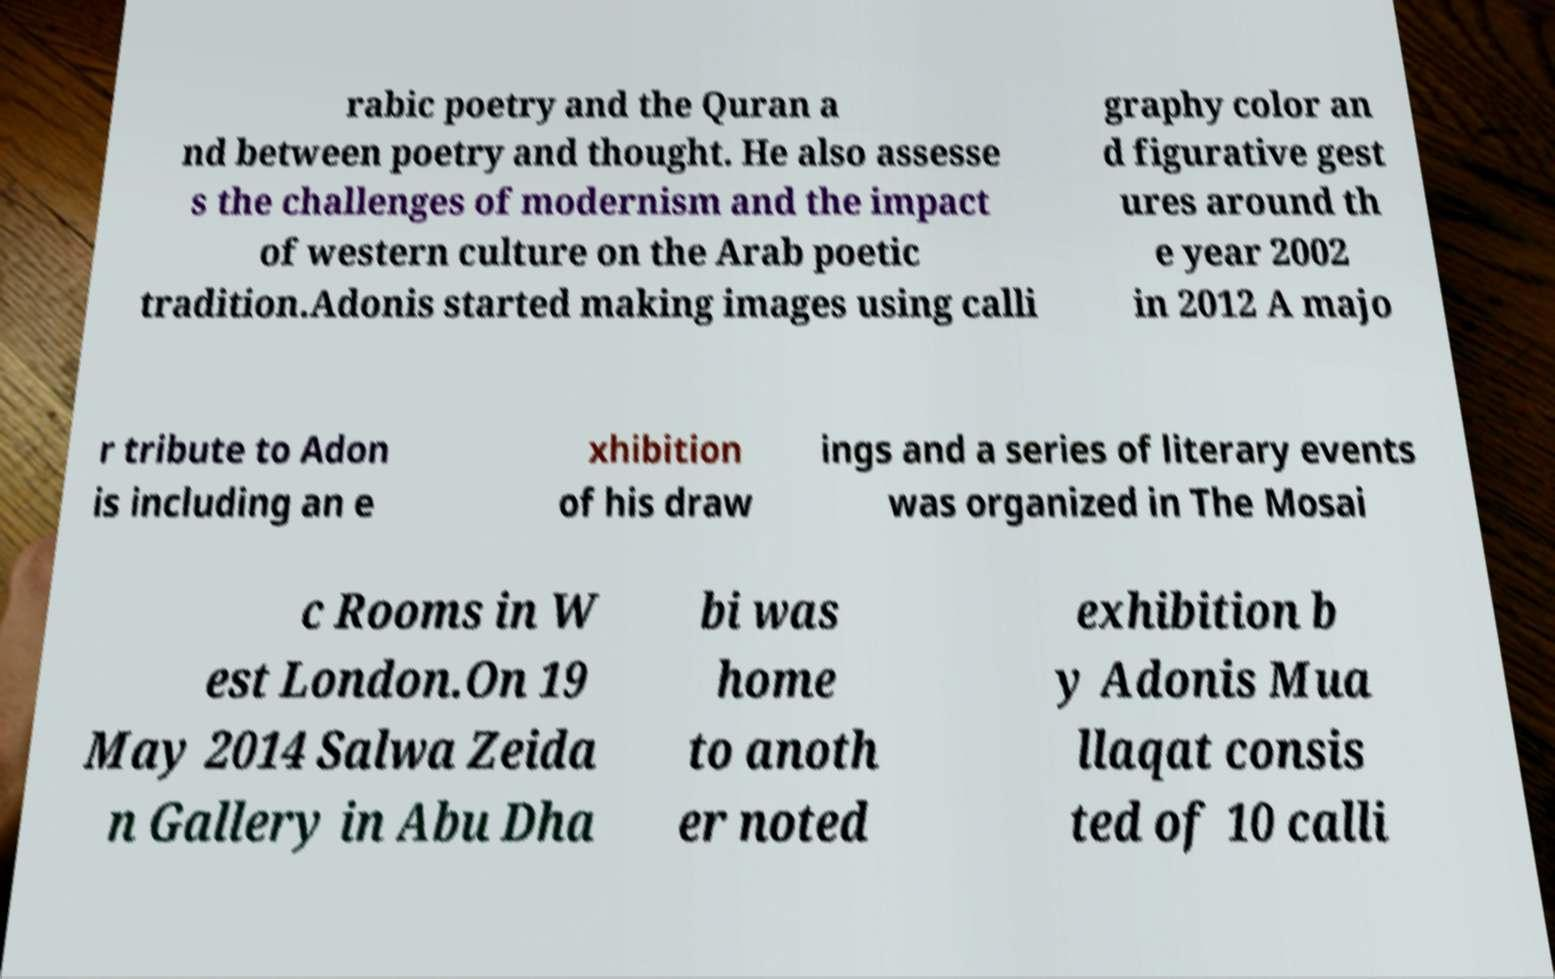Could you assist in decoding the text presented in this image and type it out clearly? rabic poetry and the Quran a nd between poetry and thought. He also assesse s the challenges of modernism and the impact of western culture on the Arab poetic tradition.Adonis started making images using calli graphy color an d figurative gest ures around th e year 2002 in 2012 A majo r tribute to Adon is including an e xhibition of his draw ings and a series of literary events was organized in The Mosai c Rooms in W est London.On 19 May 2014 Salwa Zeida n Gallery in Abu Dha bi was home to anoth er noted exhibition b y Adonis Mua llaqat consis ted of 10 calli 